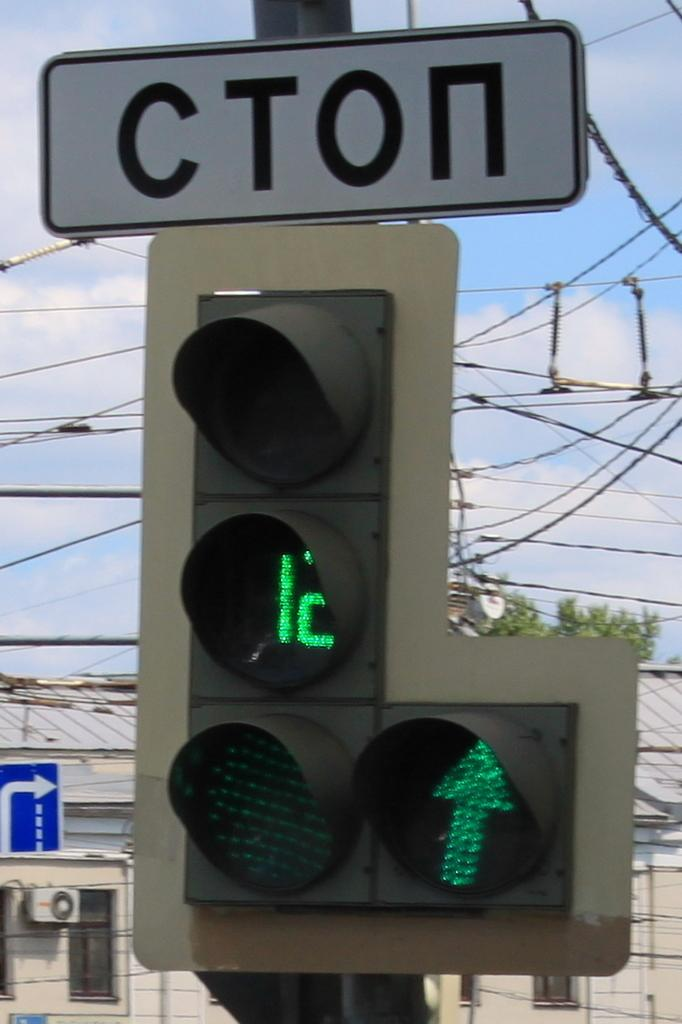<image>
Write a terse but informative summary of the picture. Cton traffic sign signal with twelve seconds left on the signal. 